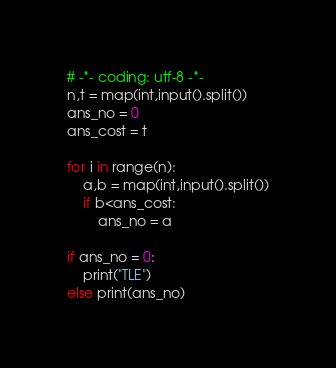<code> <loc_0><loc_0><loc_500><loc_500><_Python_># -*- coding: utf-8 -*-
n,t = map(int,input().split())
ans_no = 0
ans_cost = t

for i in range(n):
    a,b = map(int,input().split())
    if b<ans_cost:
        ans_no = a

if ans_no = 0:
    print("TLE")
else print(ans_no)</code> 